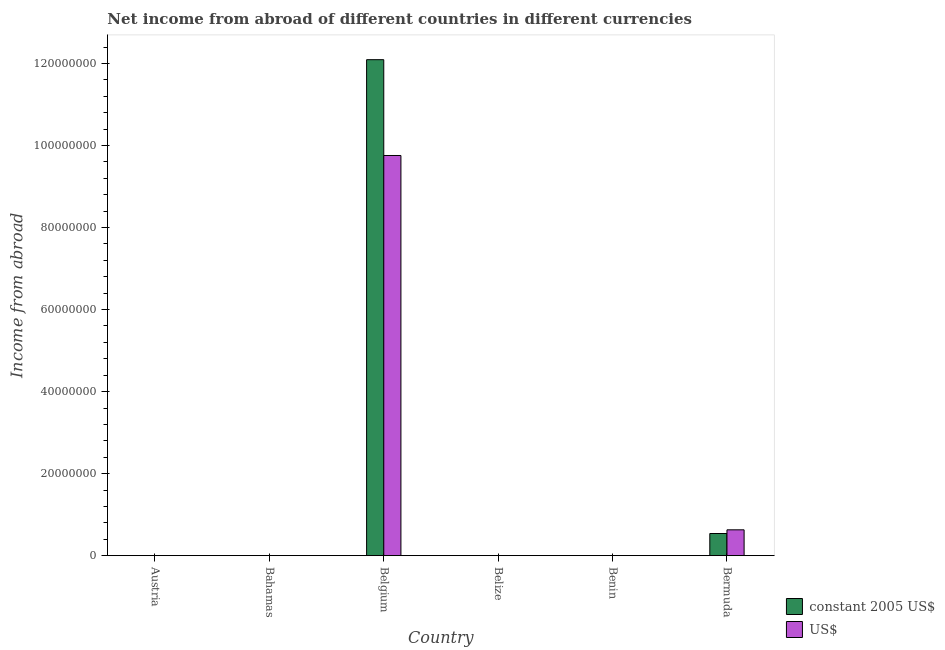How many different coloured bars are there?
Ensure brevity in your answer.  2. How many bars are there on the 2nd tick from the right?
Provide a short and direct response. 0. What is the label of the 6th group of bars from the left?
Provide a succinct answer. Bermuda. What is the income from abroad in us$ in Belgium?
Your answer should be very brief. 9.76e+07. Across all countries, what is the maximum income from abroad in constant 2005 us$?
Your answer should be very brief. 1.21e+08. Across all countries, what is the minimum income from abroad in us$?
Your response must be concise. 0. In which country was the income from abroad in us$ maximum?
Your answer should be very brief. Belgium. What is the total income from abroad in constant 2005 us$ in the graph?
Ensure brevity in your answer.  1.26e+08. What is the difference between the income from abroad in us$ in Belgium and that in Bermuda?
Provide a succinct answer. 9.13e+07. What is the difference between the income from abroad in constant 2005 us$ in Bermuda and the income from abroad in us$ in Austria?
Offer a terse response. 5.40e+06. What is the average income from abroad in constant 2005 us$ per country?
Provide a succinct answer. 2.11e+07. What is the difference between the income from abroad in constant 2005 us$ and income from abroad in us$ in Belgium?
Offer a terse response. 2.34e+07. What is the difference between the highest and the lowest income from abroad in constant 2005 us$?
Offer a terse response. 1.21e+08. Is the sum of the income from abroad in constant 2005 us$ in Belgium and Bermuda greater than the maximum income from abroad in us$ across all countries?
Ensure brevity in your answer.  Yes. Are all the bars in the graph horizontal?
Your answer should be very brief. No. Are the values on the major ticks of Y-axis written in scientific E-notation?
Keep it short and to the point. No. Where does the legend appear in the graph?
Your response must be concise. Bottom right. How many legend labels are there?
Your answer should be compact. 2. How are the legend labels stacked?
Make the answer very short. Vertical. What is the title of the graph?
Make the answer very short. Net income from abroad of different countries in different currencies. Does "Sanitation services" appear as one of the legend labels in the graph?
Make the answer very short. No. What is the label or title of the X-axis?
Make the answer very short. Country. What is the label or title of the Y-axis?
Your response must be concise. Income from abroad. What is the Income from abroad in constant 2005 US$ in Austria?
Your answer should be compact. 0. What is the Income from abroad in constant 2005 US$ in Belgium?
Your response must be concise. 1.21e+08. What is the Income from abroad in US$ in Belgium?
Ensure brevity in your answer.  9.76e+07. What is the Income from abroad of constant 2005 US$ in Belize?
Provide a short and direct response. 0. What is the Income from abroad of US$ in Belize?
Give a very brief answer. 0. What is the Income from abroad of US$ in Benin?
Your answer should be very brief. 0. What is the Income from abroad of constant 2005 US$ in Bermuda?
Your answer should be compact. 5.40e+06. What is the Income from abroad of US$ in Bermuda?
Give a very brief answer. 6.30e+06. Across all countries, what is the maximum Income from abroad of constant 2005 US$?
Keep it short and to the point. 1.21e+08. Across all countries, what is the maximum Income from abroad of US$?
Provide a short and direct response. 9.76e+07. Across all countries, what is the minimum Income from abroad of constant 2005 US$?
Provide a short and direct response. 0. What is the total Income from abroad in constant 2005 US$ in the graph?
Offer a very short reply. 1.26e+08. What is the total Income from abroad of US$ in the graph?
Provide a short and direct response. 1.04e+08. What is the difference between the Income from abroad of constant 2005 US$ in Belgium and that in Bermuda?
Make the answer very short. 1.16e+08. What is the difference between the Income from abroad in US$ in Belgium and that in Bermuda?
Provide a succinct answer. 9.13e+07. What is the difference between the Income from abroad in constant 2005 US$ in Belgium and the Income from abroad in US$ in Bermuda?
Your answer should be compact. 1.15e+08. What is the average Income from abroad of constant 2005 US$ per country?
Your answer should be compact. 2.11e+07. What is the average Income from abroad in US$ per country?
Provide a short and direct response. 1.73e+07. What is the difference between the Income from abroad of constant 2005 US$ and Income from abroad of US$ in Belgium?
Offer a terse response. 2.34e+07. What is the difference between the Income from abroad of constant 2005 US$ and Income from abroad of US$ in Bermuda?
Offer a terse response. -9.00e+05. What is the ratio of the Income from abroad of constant 2005 US$ in Belgium to that in Bermuda?
Provide a short and direct response. 22.4. What is the ratio of the Income from abroad of US$ in Belgium to that in Bermuda?
Provide a succinct answer. 15.49. What is the difference between the highest and the lowest Income from abroad in constant 2005 US$?
Your answer should be compact. 1.21e+08. What is the difference between the highest and the lowest Income from abroad in US$?
Make the answer very short. 9.76e+07. 